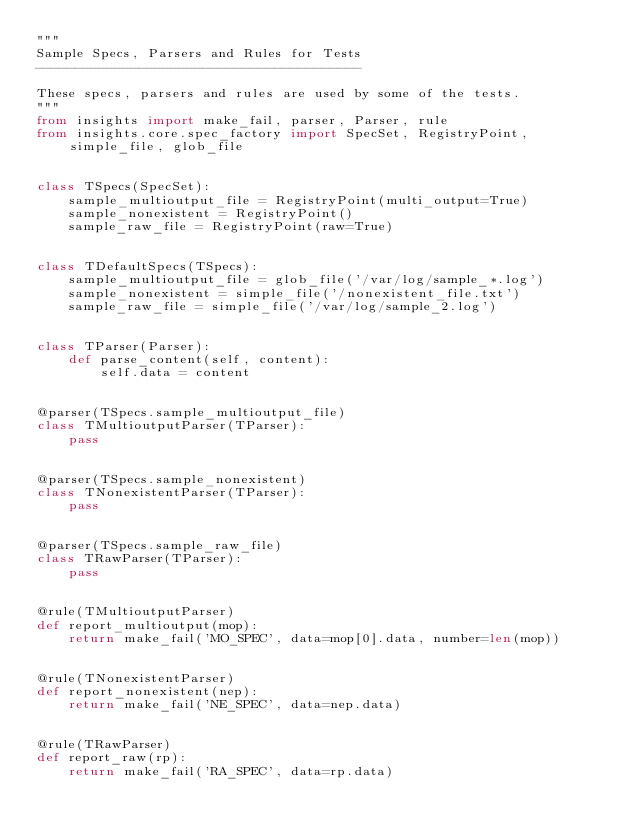Convert code to text. <code><loc_0><loc_0><loc_500><loc_500><_Python_>"""
Sample Specs, Parsers and Rules for Tests
-----------------------------------------

These specs, parsers and rules are used by some of the tests.
"""
from insights import make_fail, parser, Parser, rule
from insights.core.spec_factory import SpecSet, RegistryPoint, simple_file, glob_file


class TSpecs(SpecSet):
    sample_multioutput_file = RegistryPoint(multi_output=True)
    sample_nonexistent = RegistryPoint()
    sample_raw_file = RegistryPoint(raw=True)


class TDefaultSpecs(TSpecs):
    sample_multioutput_file = glob_file('/var/log/sample_*.log')
    sample_nonexistent = simple_file('/nonexistent_file.txt')
    sample_raw_file = simple_file('/var/log/sample_2.log')


class TParser(Parser):
    def parse_content(self, content):
        self.data = content


@parser(TSpecs.sample_multioutput_file)
class TMultioutputParser(TParser):
    pass


@parser(TSpecs.sample_nonexistent)
class TNonexistentParser(TParser):
    pass


@parser(TSpecs.sample_raw_file)
class TRawParser(TParser):
    pass


@rule(TMultioutputParser)
def report_multioutput(mop):
    return make_fail('MO_SPEC', data=mop[0].data, number=len(mop))


@rule(TNonexistentParser)
def report_nonexistent(nep):
    return make_fail('NE_SPEC', data=nep.data)


@rule(TRawParser)
def report_raw(rp):
    return make_fail('RA_SPEC', data=rp.data)
</code> 